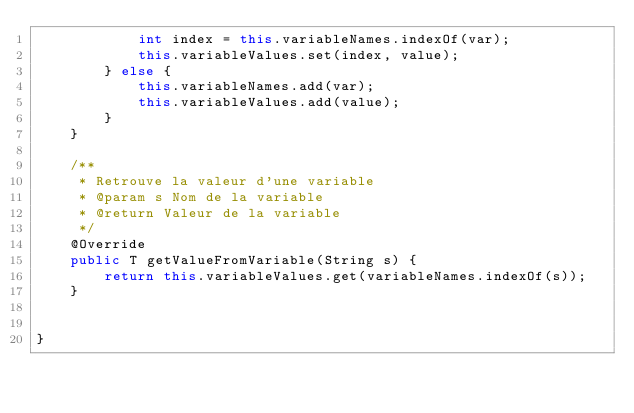<code> <loc_0><loc_0><loc_500><loc_500><_Java_>            int index = this.variableNames.indexOf(var);
            this.variableValues.set(index, value);
        } else {
            this.variableNames.add(var);
            this.variableValues.add(value);
        }
    }

    /**
     * Retrouve la valeur d'une variable
     * @param s Nom de la variable
     * @return Valeur de la variable
     */
    @Override
    public T getValueFromVariable(String s) {
        return this.variableValues.get(variableNames.indexOf(s));
    }


}
</code> 